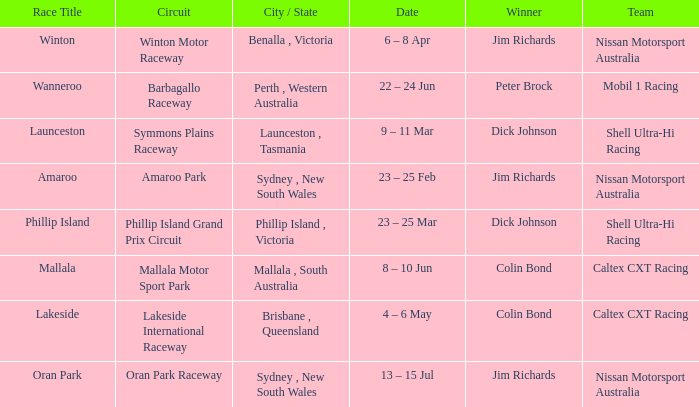Name the date for race title lakeside 4 – 6 May. 